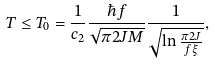Convert formula to latex. <formula><loc_0><loc_0><loc_500><loc_500>T \leq T _ { 0 } = \frac { 1 } { c _ { 2 } } \frac { \hbar { f } } { \sqrt { \pi 2 J M } } \frac { 1 } { \sqrt { \ln { \frac { \pi 2 J } { f \xi } } } } ,</formula> 